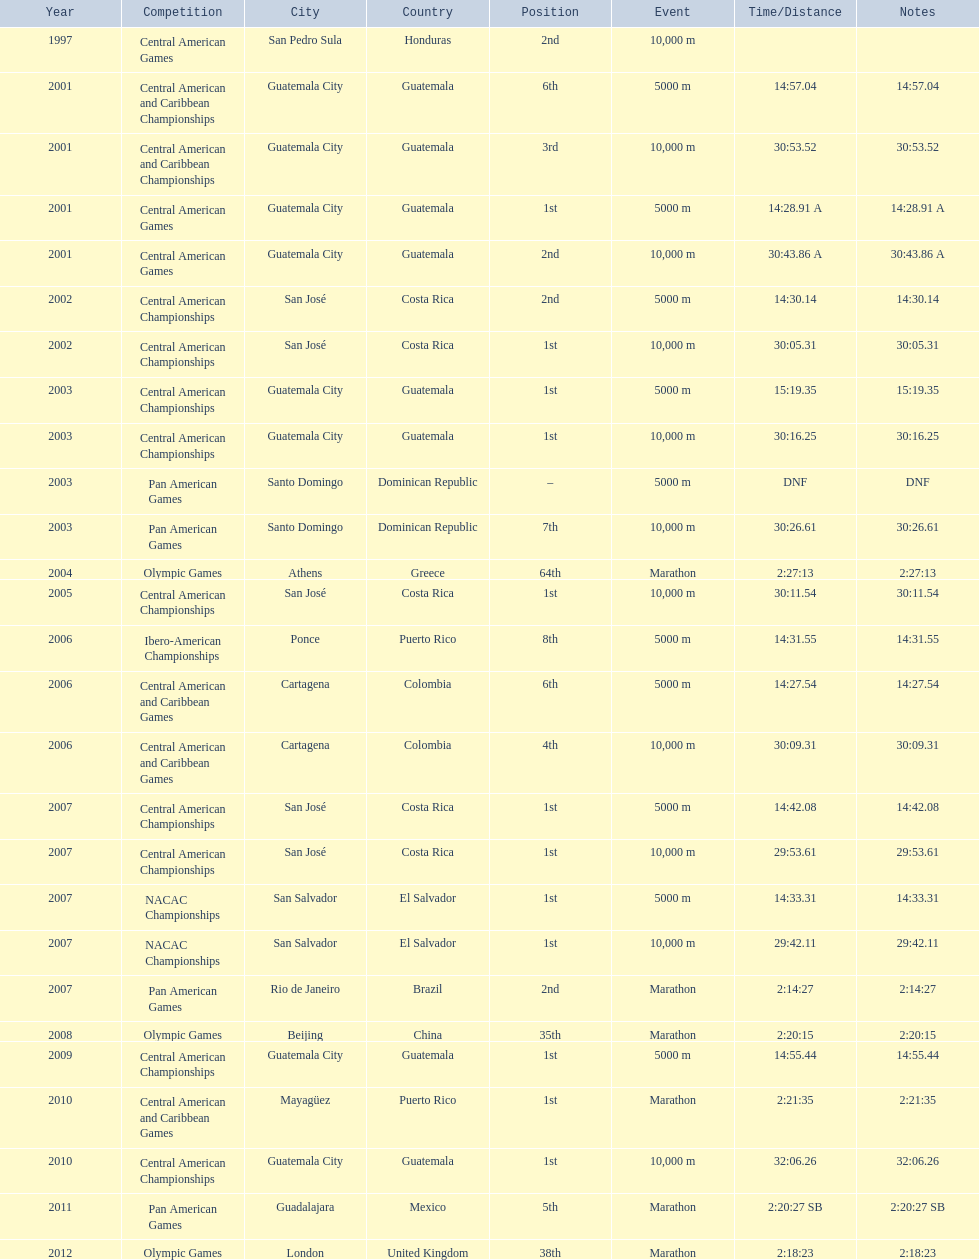How many times has this athlete not finished in a competition? 1. 